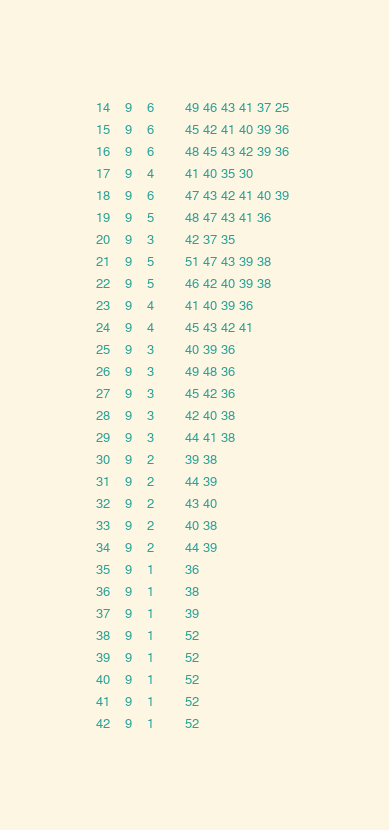Convert code to text. <code><loc_0><loc_0><loc_500><loc_500><_ObjectiveC_>14	9	6		49 46 43 41 37 25 
15	9	6		45 42 41 40 39 36 
16	9	6		48 45 43 42 39 36 
17	9	4		41 40 35 30 
18	9	6		47 43 42 41 40 39 
19	9	5		48 47 43 41 36 
20	9	3		42 37 35 
21	9	5		51 47 43 39 38 
22	9	5		46 42 40 39 38 
23	9	4		41 40 39 36 
24	9	4		45 43 42 41 
25	9	3		40 39 36 
26	9	3		49 48 36 
27	9	3		45 42 36 
28	9	3		42 40 38 
29	9	3		44 41 38 
30	9	2		39 38 
31	9	2		44 39 
32	9	2		43 40 
33	9	2		40 38 
34	9	2		44 39 
35	9	1		36 
36	9	1		38 
37	9	1		39 
38	9	1		52 
39	9	1		52 
40	9	1		52 
41	9	1		52 
42	9	1		52 </code> 